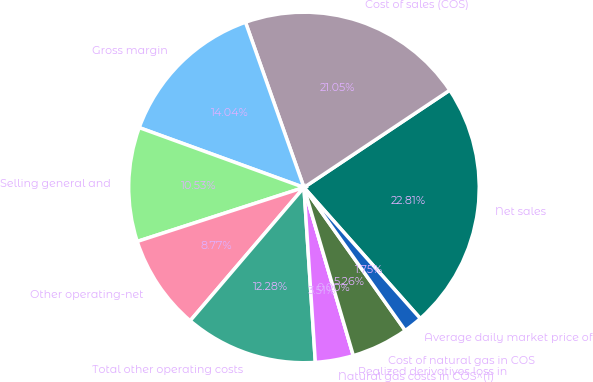Convert chart to OTSL. <chart><loc_0><loc_0><loc_500><loc_500><pie_chart><fcel>Net sales<fcel>Cost of sales (COS)<fcel>Gross margin<fcel>Selling general and<fcel>Other operating-net<fcel>Total other operating costs<fcel>Natural gas costs in COS^(1)<fcel>Realized derivatives loss in<fcel>Cost of natural gas in COS<fcel>Average daily market price of<nl><fcel>22.81%<fcel>21.05%<fcel>14.04%<fcel>10.53%<fcel>8.77%<fcel>12.28%<fcel>3.51%<fcel>0.0%<fcel>5.26%<fcel>1.75%<nl></chart> 